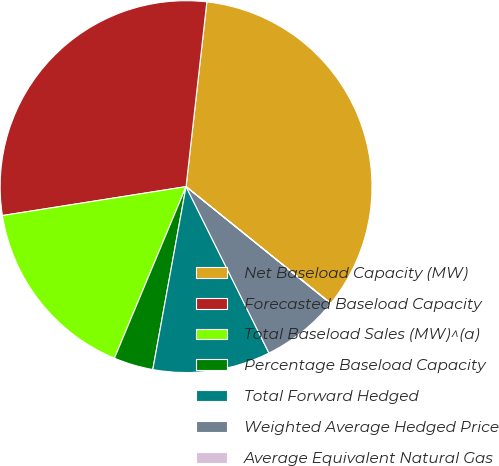Convert chart to OTSL. <chart><loc_0><loc_0><loc_500><loc_500><pie_chart><fcel>Net Baseload Capacity (MW)<fcel>Forecasted Baseload Capacity<fcel>Total Baseload Sales (MW)^(a)<fcel>Percentage Baseload Capacity<fcel>Total Forward Hedged<fcel>Weighted Average Hedged Price<fcel>Average Equivalent Natural Gas<nl><fcel>34.01%<fcel>29.27%<fcel>16.22%<fcel>3.43%<fcel>10.22%<fcel>6.82%<fcel>0.03%<nl></chart> 